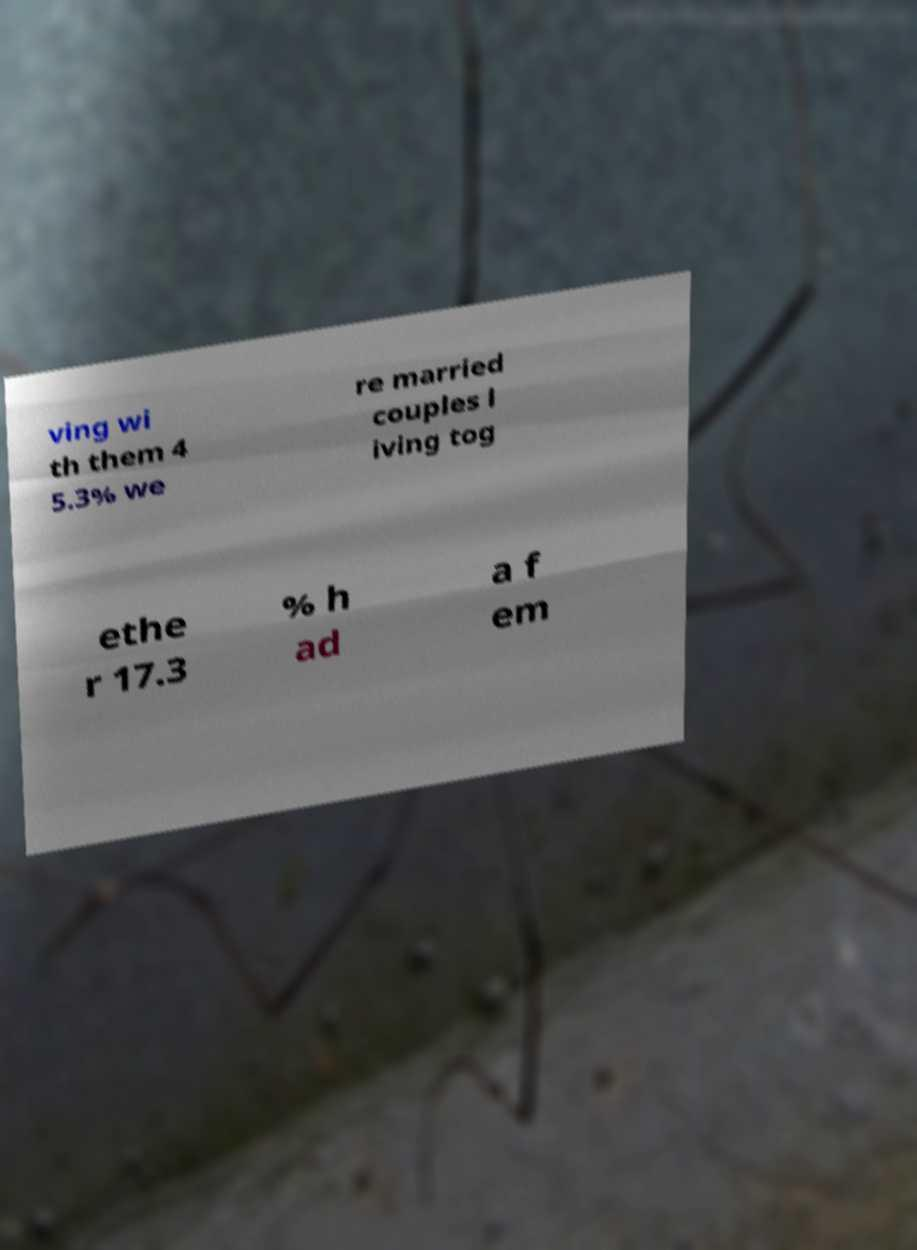Can you read and provide the text displayed in the image?This photo seems to have some interesting text. Can you extract and type it out for me? ving wi th them 4 5.3% we re married couples l iving tog ethe r 17.3 % h ad a f em 